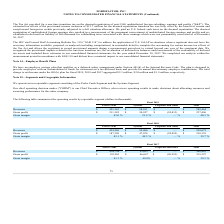According to Formfactor's financial document, What does corporate and others include? Based on the financial document, the answer is includes unallocated expenses relating to amortization of intangible assets, share-based compensation expense, acquisition-related costs, including charges related to inventory stepped up to fair value, and other costs, which are not used in evaluating the results of, or in allocating resources to, our reportable segments.. Also, What was the revenues from different segments in 2017? The document contains multiple relevant values: 454,794, 93,647, 0. From the document: "Revenues $ 454,794 $ 93,647 $ — $ 548,441 Revenues $ 454,794 $ 93,647 $ — $ 548,441 Revenues $ 454,794 $ 93,647 $ — $ 548,441..." Also, What are the different streams of revenue? The document contains multiple relevant values: Probe Cards, Systems, Corporate and Other. From the document: "Probe Cards Systems Corporate and Other Total Probe Cards Systems Corporate and Other Total Probe Cards Systems Corporate and Other Total..." Also, can you calculate: What percentage of total revenue is probe cards revenue in 2017? Based on the calculation: 454,794 / 548,441, the result is 0.83. This is based on the information: "Revenues $ 454,794 $ 93,647 $ — $ 548,441 Revenues $ 454,794 $ 93,647 $ — $ 548,441..." The key data points involved are: 454,794, 548,441. Also, can you calculate: What is the increase / (decrease) in the probe cards revenue from 2018 to 2019? Based on the calculation: 491,363 - 434,269, the result is 57094. This is based on the information: "Revenues $ 434,269 $ 95,406 $ — $ 529,675 Revenues $ 491,363 $ 98,101 $ — $ 589,464..." The key data points involved are: 434,269, 491,363. Also, can you calculate: What is the average revenue in 2017? To answer this question, I need to perform calculations using the financial data. The calculation is: (454,794 + 93,647 + 0) / 3, which equals 182813.67. This is based on the information: "Revenues $ 454,794 $ 93,647 $ — $ 548,441 Revenues $ 454,794 $ 93,647 $ — $ 548,441 Revenues $ 454,794 $ 93,647 $ — $ 548,441..." The key data points involved are: 0, 454,794, 93,647. 